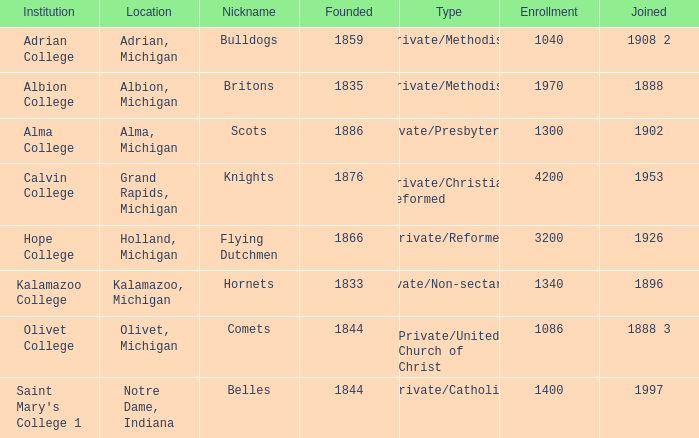How many categories fall under the category of britons? 1.0. 